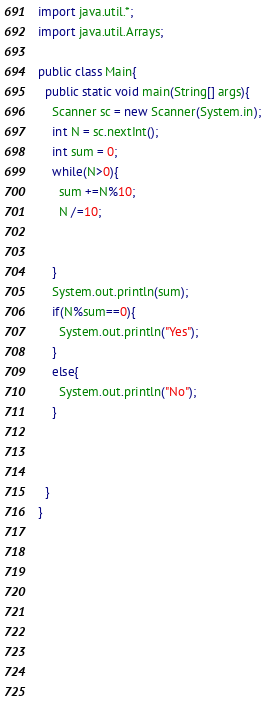Convert code to text. <code><loc_0><loc_0><loc_500><loc_500><_Java_>import java.util.*;
import java.util.Arrays;

public class Main{
  public static void main(String[] args){
    Scanner sc = new Scanner(System.in);
    int N = sc.nextInt();
    int sum = 0;
    while(N>0){
      sum +=N%10;
      N /=10;


    }
    System.out.println(sum);
    if(N%sum==0){
      System.out.println("Yes");
    }
    else{
      System.out.println("No");
    }


    
  }
}
                          
                         
                    
    
    
    
    
    
    
</code> 